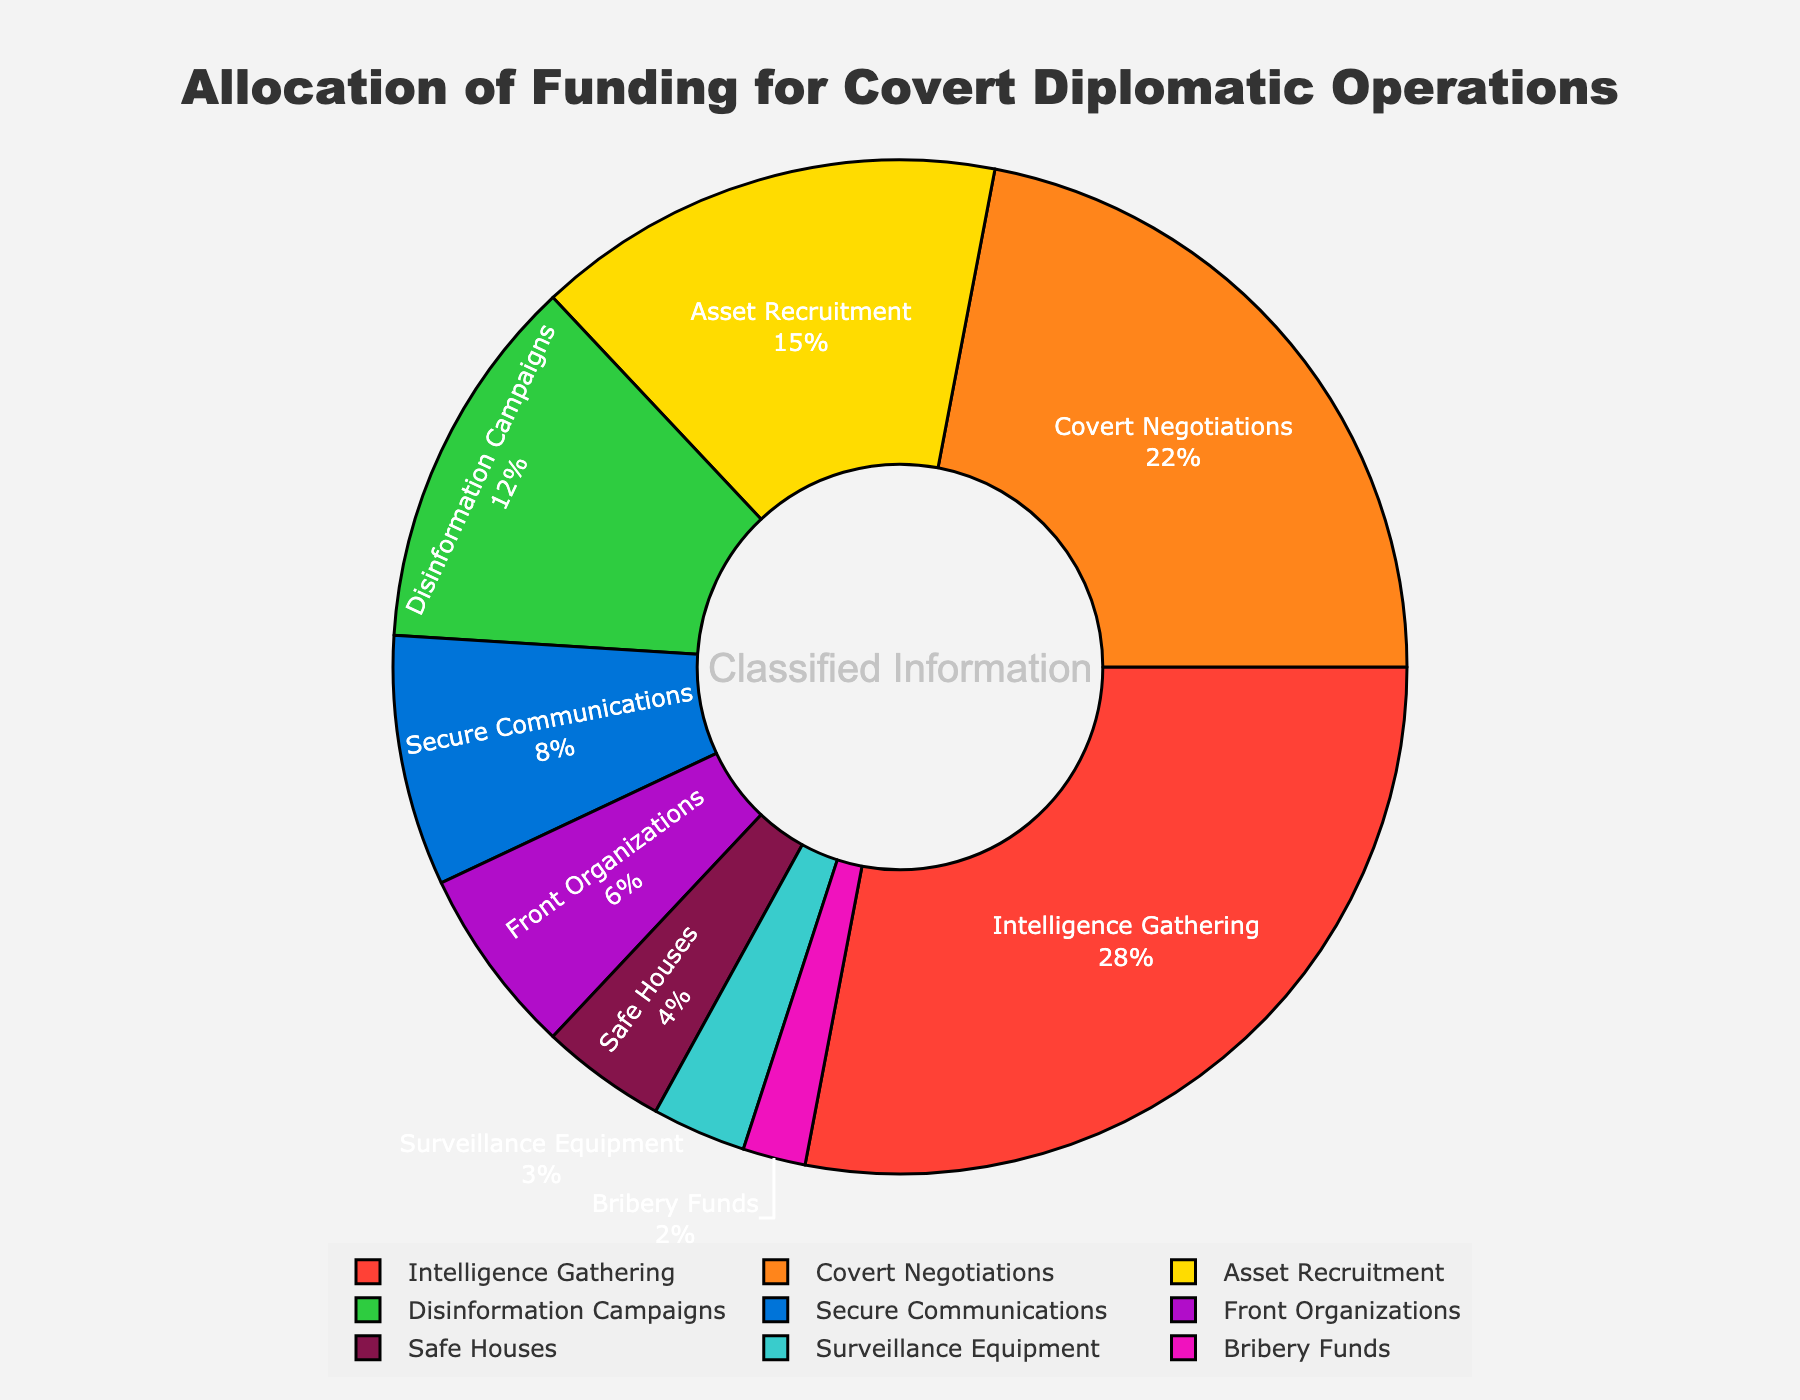What are the top two categories in terms of funding allocation? The figure shows a pie chart with segments labeled and their percentages. The two segments with the highest percentages are "Intelligence Gathering" (28%) and "Covert Negotiations" (22%).
Answer: Intelligence Gathering and Covert Negotiations Which category receives less funding, Safe Houses or Front Organizations? By comparing the percentages in the pie chart, Safe Houses have 4% while Front Organizations have 6%. Therefore, Safe Houses receive less funding.
Answer: Safe Houses What is the combined percentage of funding allocated to Secure Communications and Surveillance Equipment? Secure Communications has 8% and Surveillance Equipment has 3%. Adding these together, we get 8% + 3% = 11%.
Answer: 11% By how much does the funding for Intelligence Gathering exceed that for Asset Recruitment? Intelligence Gathering has 28% while Asset Recruitment has 15%. Subtracting these, 28% - 15% = 13%.
Answer: 13% Are there more categories allocated less than 10% or more than 10% of funding? Categories with less than 10% funding are Secure Communications (8%), Front Organizations (6%), Safe Houses (4%), Surveillance Equipment (3%), and Bribery Funds (2%), totaling 5 categories. Categories with more than 10% are Intelligence Gathering (28%), Covert Negotiations (22%), Asset Recruitment (15%), and Disinformation Campaigns (12%), totaling 4 categories.
Answer: Less than 10% Which category is represented by the green color in the chart? The green segment is closest to "Secure Communications" with 8%.
Answer: Secure Communications If the funding for Disinformation Campaigns was equally divided among Covert Negotiations and Asset Recruitment, what would be the new percentages for these categories? Currently, Disinformation Campaigns have 12%. This would be split equally between Covert Negotiations and Asset Recruitment, giving each 6% extra. Covert Negotiations would then have 22% + 6% = 28% and Asset Recruitment would have 15% + 6% = 21%.
Answer: Covert Negotiations: 28%, Asset Recruitment: 21% What proportion of total funding does the combination of the two smallest categories represent? The smallest categories are Bribery Funds (2%) and Surveillance Equipment (3%). Combined, they make 2% + 3% = 5%.
Answer: 5% How does the funding for Disinformation Campaigns compare to Asset Recruitment? Disinformation Campaigns have 12% and Asset Recruitment has 15%. Comparing these, Asset Recruitment has a higher percentage.
Answer: Asset Recruitment has more What is the funding share allocated to Front Organizations if it was expressed as a fraction? Front Organizations have 6%. This can be written as 6/100, which simplifies to 3/50.
Answer: 3/50 